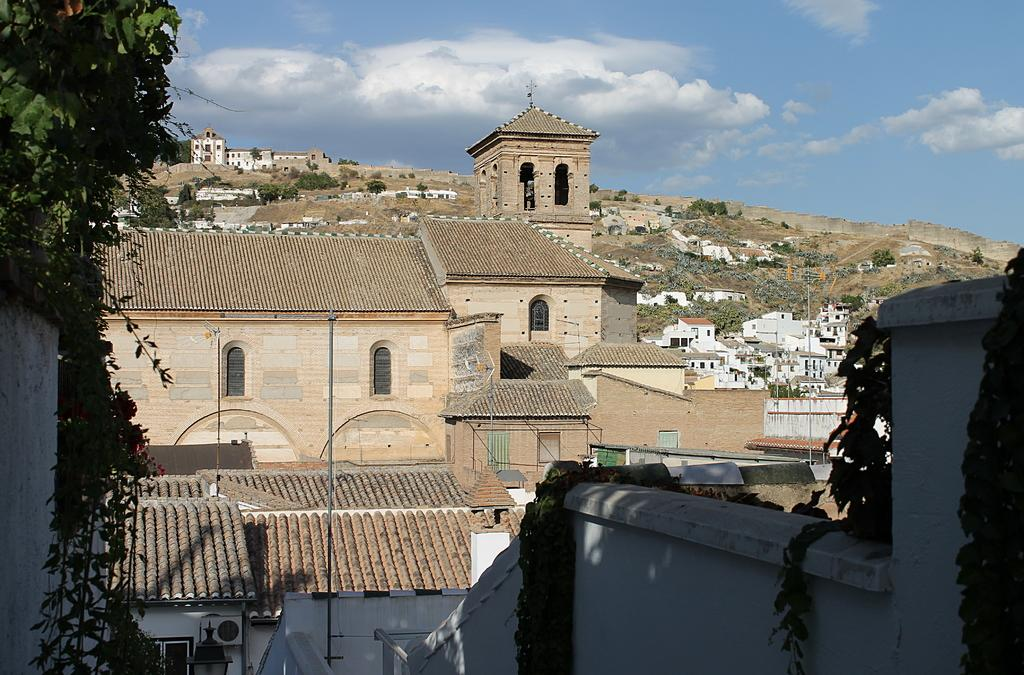What type of structures can be seen in the image? There are buildings in the image. What other natural elements are present in the image? There are trees in the image. What can be seen in the distance in the image? The sky is visible in the background of the image. How many dimes are placed on top of the tallest building in the image? There are no dimes present in the image, and therefore no such arrangement can be observed. 